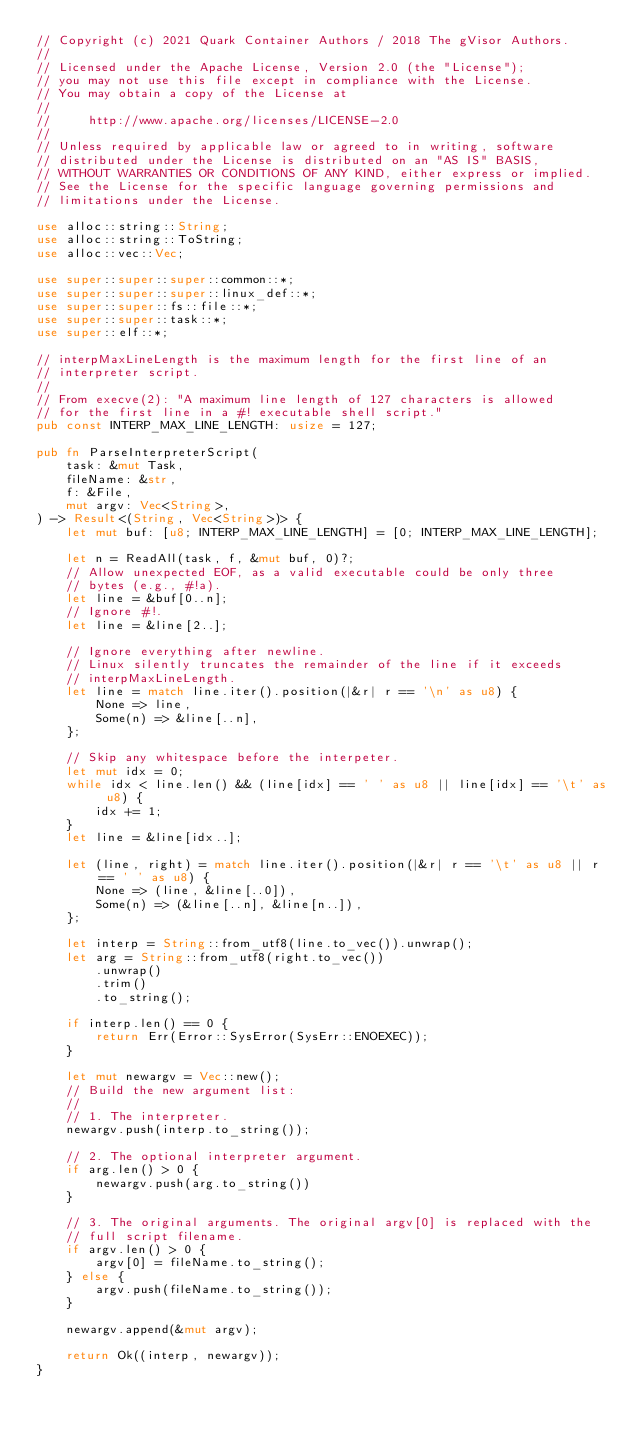Convert code to text. <code><loc_0><loc_0><loc_500><loc_500><_Rust_>// Copyright (c) 2021 Quark Container Authors / 2018 The gVisor Authors.
//
// Licensed under the Apache License, Version 2.0 (the "License");
// you may not use this file except in compliance with the License.
// You may obtain a copy of the License at
//
//     http://www.apache.org/licenses/LICENSE-2.0
//
// Unless required by applicable law or agreed to in writing, software
// distributed under the License is distributed on an "AS IS" BASIS,
// WITHOUT WARRANTIES OR CONDITIONS OF ANY KIND, either express or implied.
// See the License for the specific language governing permissions and
// limitations under the License.

use alloc::string::String;
use alloc::string::ToString;
use alloc::vec::Vec;

use super::super::super::common::*;
use super::super::super::linux_def::*;
use super::super::fs::file::*;
use super::super::task::*;
use super::elf::*;

// interpMaxLineLength is the maximum length for the first line of an
// interpreter script.
//
// From execve(2): "A maximum line length of 127 characters is allowed
// for the first line in a #! executable shell script."
pub const INTERP_MAX_LINE_LENGTH: usize = 127;

pub fn ParseInterpreterScript(
    task: &mut Task,
    fileName: &str,
    f: &File,
    mut argv: Vec<String>,
) -> Result<(String, Vec<String>)> {
    let mut buf: [u8; INTERP_MAX_LINE_LENGTH] = [0; INTERP_MAX_LINE_LENGTH];

    let n = ReadAll(task, f, &mut buf, 0)?;
    // Allow unexpected EOF, as a valid executable could be only three
    // bytes (e.g., #!a).
    let line = &buf[0..n];
    // Ignore #!.
    let line = &line[2..];

    // Ignore everything after newline.
    // Linux silently truncates the remainder of the line if it exceeds
    // interpMaxLineLength.
    let line = match line.iter().position(|&r| r == '\n' as u8) {
        None => line,
        Some(n) => &line[..n],
    };

    // Skip any whitespace before the interpeter.
    let mut idx = 0;
    while idx < line.len() && (line[idx] == ' ' as u8 || line[idx] == '\t' as u8) {
        idx += 1;
    }
    let line = &line[idx..];

    let (line, right) = match line.iter().position(|&r| r == '\t' as u8 || r == ' ' as u8) {
        None => (line, &line[..0]),
        Some(n) => (&line[..n], &line[n..]),
    };

    let interp = String::from_utf8(line.to_vec()).unwrap();
    let arg = String::from_utf8(right.to_vec())
        .unwrap()
        .trim()
        .to_string();

    if interp.len() == 0 {
        return Err(Error::SysError(SysErr::ENOEXEC));
    }

    let mut newargv = Vec::new();
    // Build the new argument list:
    //
    // 1. The interpreter.
    newargv.push(interp.to_string());

    // 2. The optional interpreter argument.
    if arg.len() > 0 {
        newargv.push(arg.to_string())
    }

    // 3. The original arguments. The original argv[0] is replaced with the
    // full script filename.
    if argv.len() > 0 {
        argv[0] = fileName.to_string();
    } else {
        argv.push(fileName.to_string());
    }

    newargv.append(&mut argv);

    return Ok((interp, newargv));
}
</code> 